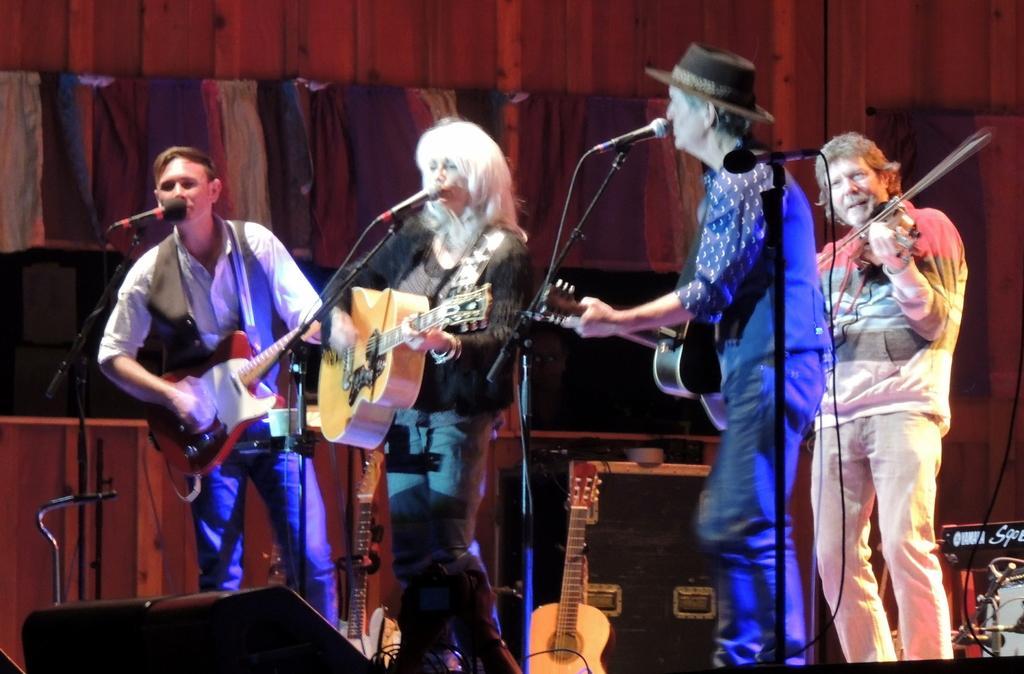In one or two sentences, can you explain what this image depicts? There are four standing. Three of them are singing a song and playing guitars and the other person is playing violin. I can see a guitar placed here. These are the mics attached to their mic stands. I think this is a speaker. These are the clothes hanging to the hanger. At the background that looks like a wooden texture wall. 